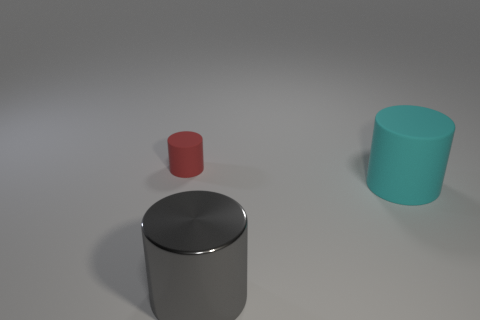Is there anything else that is the same size as the red matte cylinder?
Offer a very short reply. No. What number of blue metal spheres are there?
Ensure brevity in your answer.  0. How many yellow objects are either large rubber cylinders or rubber cylinders?
Keep it short and to the point. 0. Does the big thing on the right side of the large gray shiny cylinder have the same material as the red object?
Give a very brief answer. Yes. How many other things are there of the same material as the big cyan cylinder?
Make the answer very short. 1. What material is the red cylinder?
Provide a succinct answer. Rubber. There is a cylinder that is to the left of the gray metallic object; what is its size?
Provide a succinct answer. Small. There is a matte thing that is to the right of the tiny red cylinder; how many rubber things are to the left of it?
Ensure brevity in your answer.  1. There is a thing that is on the left side of the gray metal thing; does it have the same shape as the matte object that is in front of the tiny red matte cylinder?
Your response must be concise. Yes. What number of things are both on the right side of the red cylinder and on the left side of the large cyan matte cylinder?
Offer a terse response. 1. 